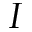Convert formula to latex. <formula><loc_0><loc_0><loc_500><loc_500>I</formula> 